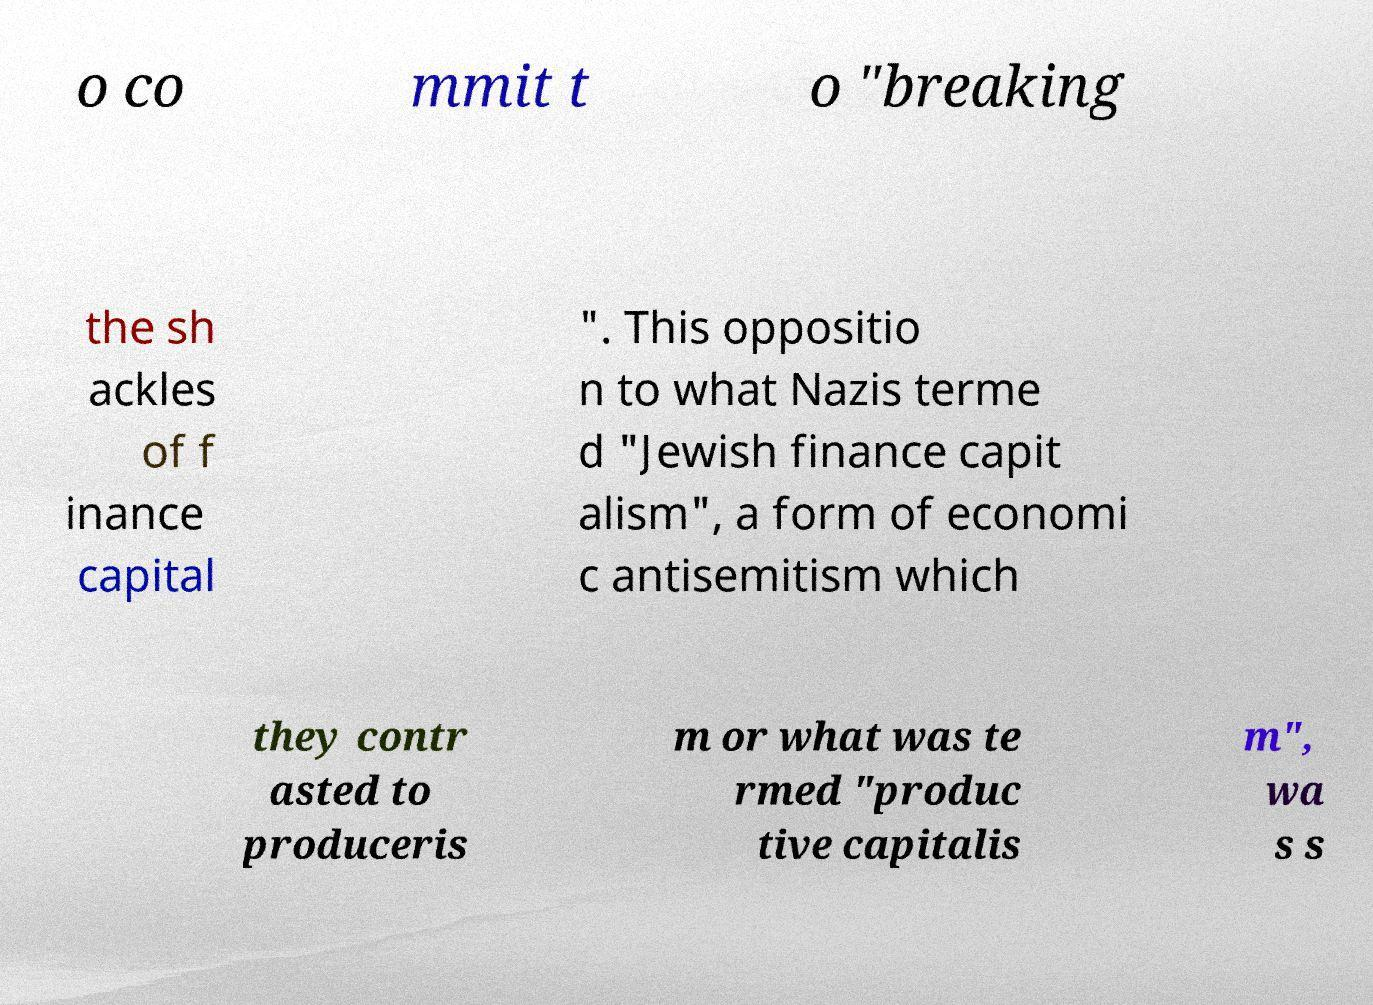Can you read and provide the text displayed in the image?This photo seems to have some interesting text. Can you extract and type it out for me? o co mmit t o "breaking the sh ackles of f inance capital ". This oppositio n to what Nazis terme d "Jewish finance capit alism", a form of economi c antisemitism which they contr asted to produceris m or what was te rmed "produc tive capitalis m", wa s s 